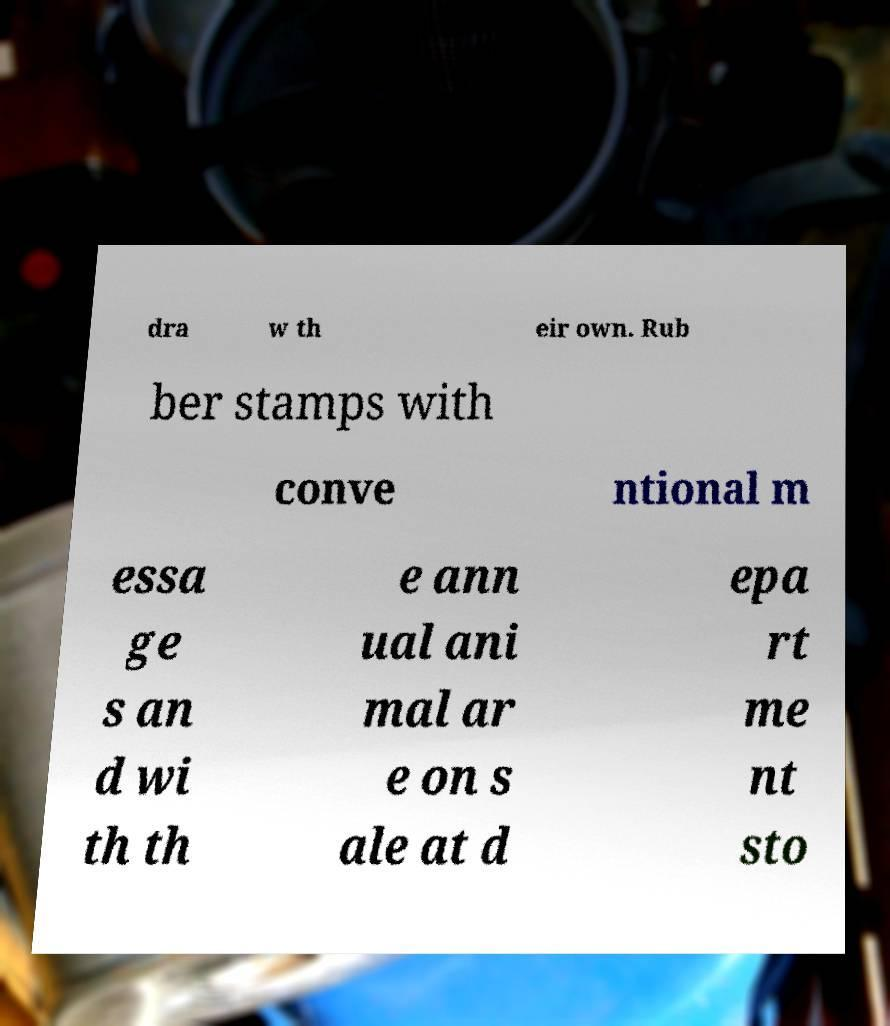Can you accurately transcribe the text from the provided image for me? dra w th eir own. Rub ber stamps with conve ntional m essa ge s an d wi th th e ann ual ani mal ar e on s ale at d epa rt me nt sto 